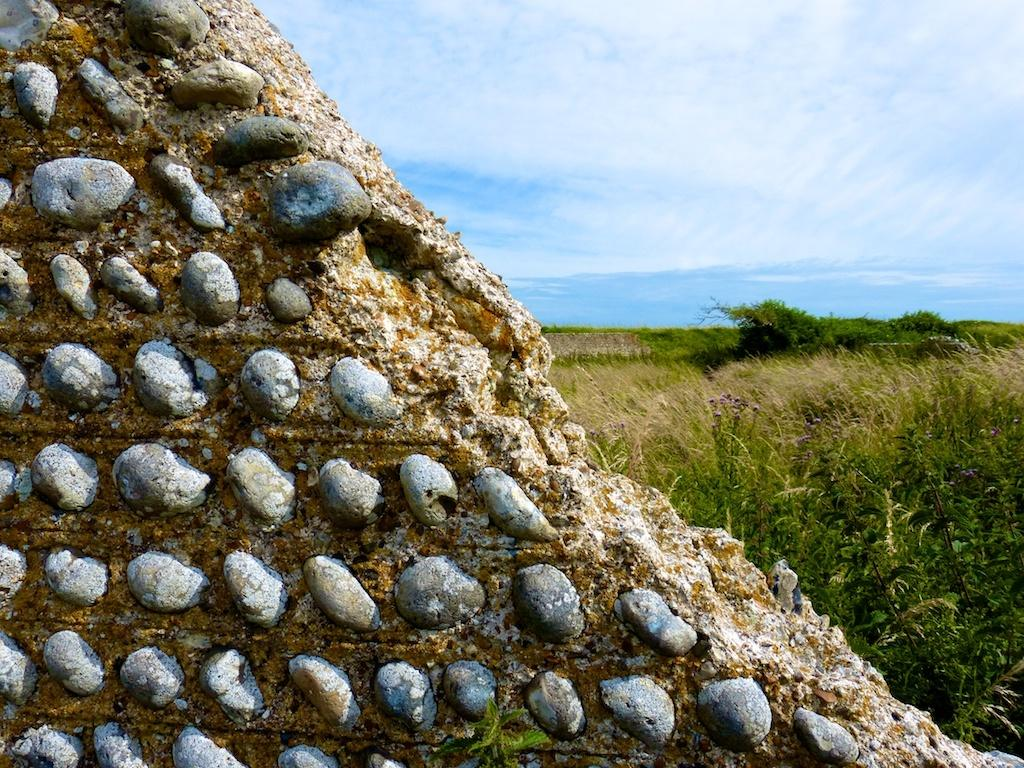What is on the wall in the image? There are stones on a wall in the image. What type of vegetation can be seen in the image? There are plants and a tree visible in the image. What type of ground cover is present in the image? There is grass in the image. What is visible in the sky in the image? The sky is visible in the image and appears cloudy. What year is depicted on the plate in the image? There is no plate present in the image, so the year cannot be determined. What causes a feeling of disgust in the image? There is no indication of anything causing a feeling of disgust in the image. 